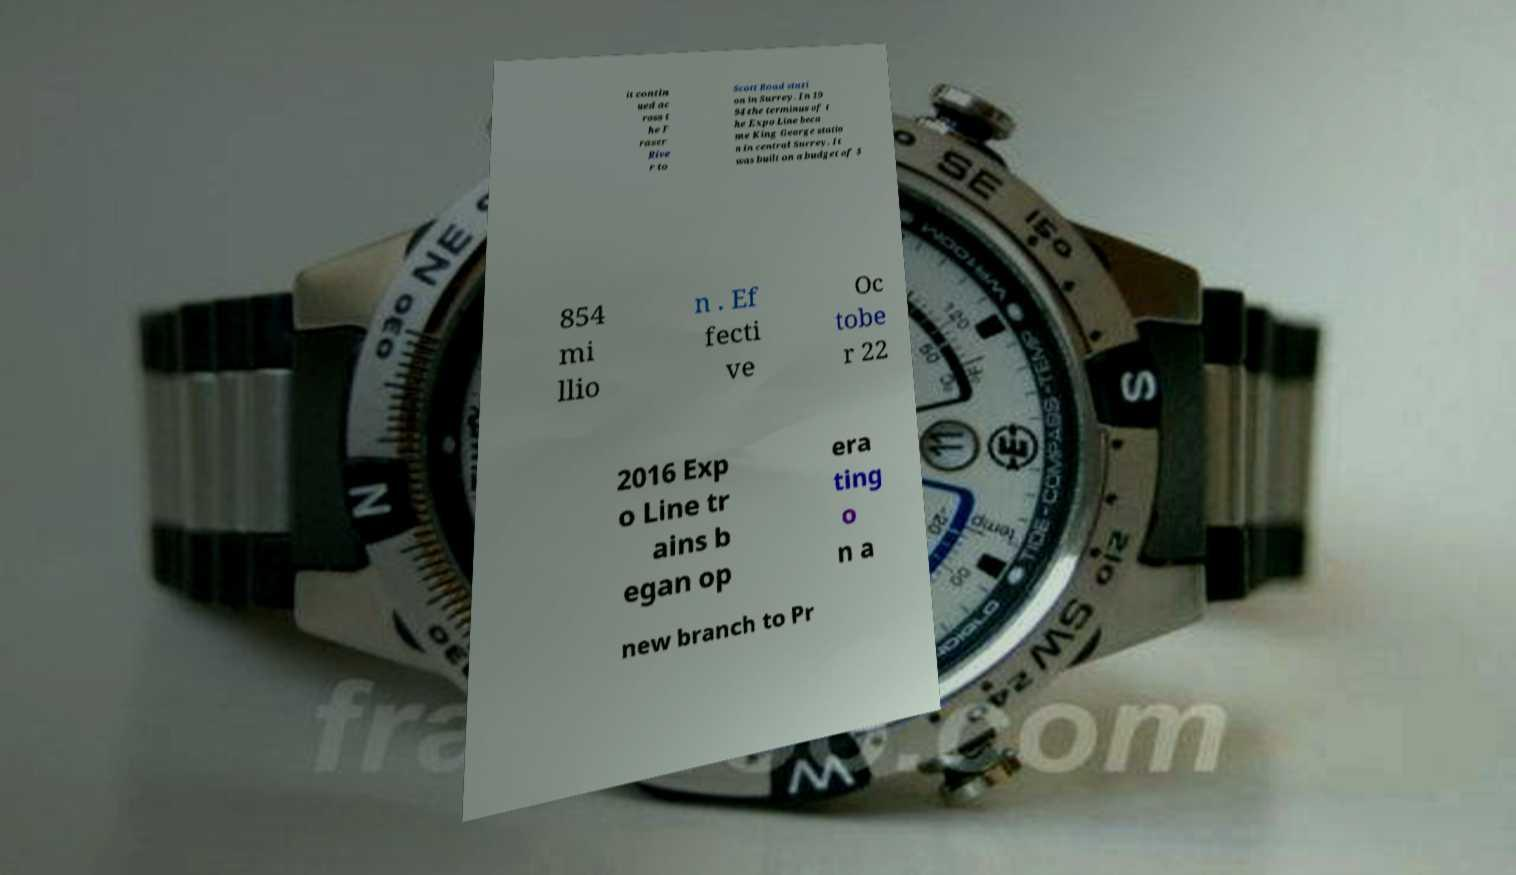Can you read and provide the text displayed in the image?This photo seems to have some interesting text. Can you extract and type it out for me? it contin ued ac ross t he F raser Rive r to Scott Road stati on in Surrey. In 19 94 the terminus of t he Expo Line beca me King George statio n in central Surrey. It was built on a budget of $ 854 mi llio n . Ef fecti ve Oc tobe r 22 2016 Exp o Line tr ains b egan op era ting o n a new branch to Pr 